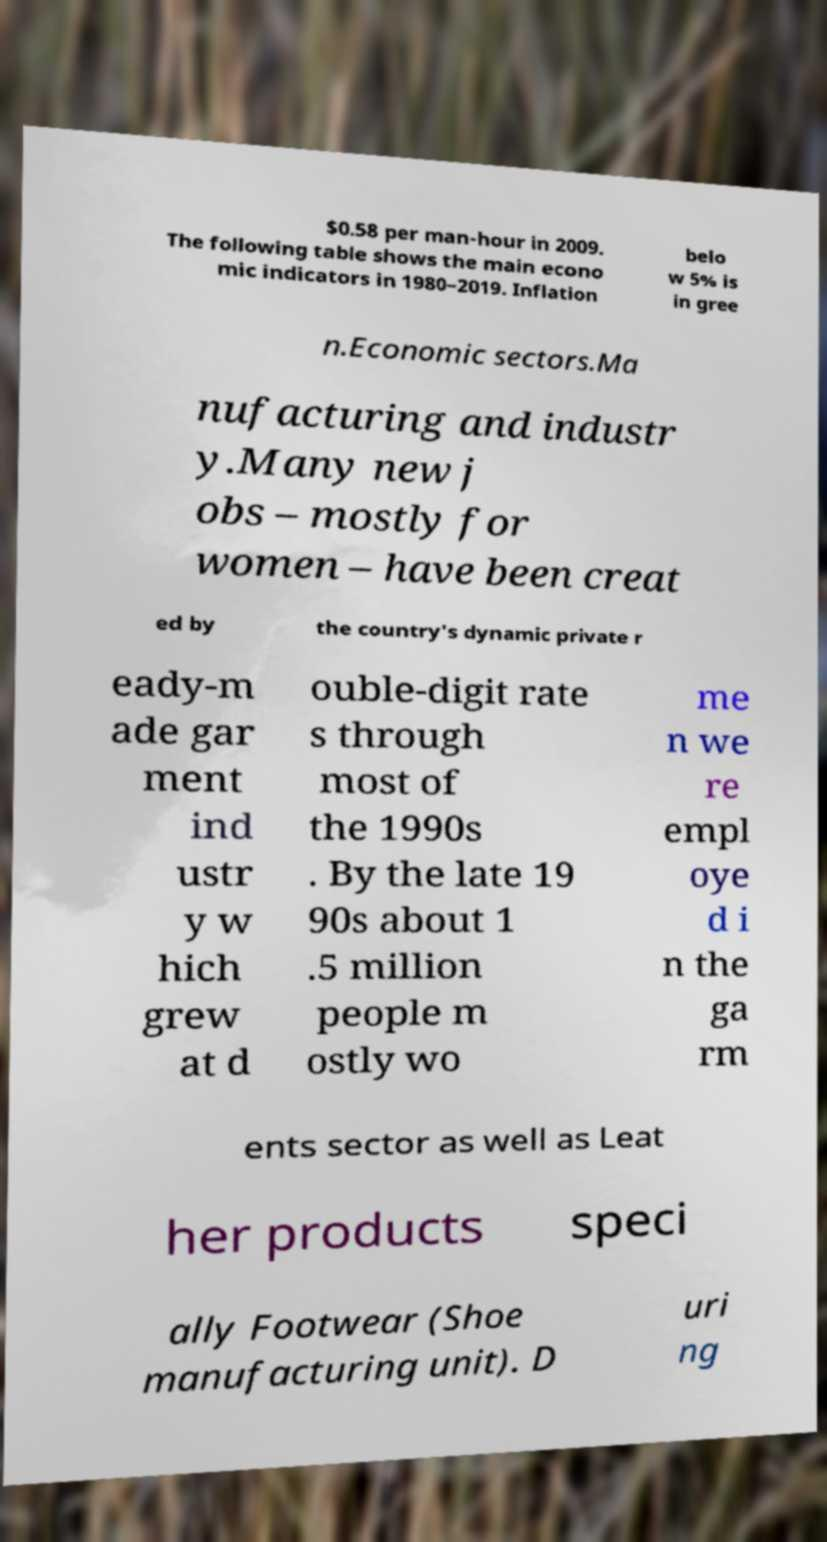There's text embedded in this image that I need extracted. Can you transcribe it verbatim? $0.58 per man-hour in 2009. The following table shows the main econo mic indicators in 1980–2019. Inflation belo w 5% is in gree n.Economic sectors.Ma nufacturing and industr y.Many new j obs – mostly for women – have been creat ed by the country's dynamic private r eady-m ade gar ment ind ustr y w hich grew at d ouble-digit rate s through most of the 1990s . By the late 19 90s about 1 .5 million people m ostly wo me n we re empl oye d i n the ga rm ents sector as well as Leat her products speci ally Footwear (Shoe manufacturing unit). D uri ng 